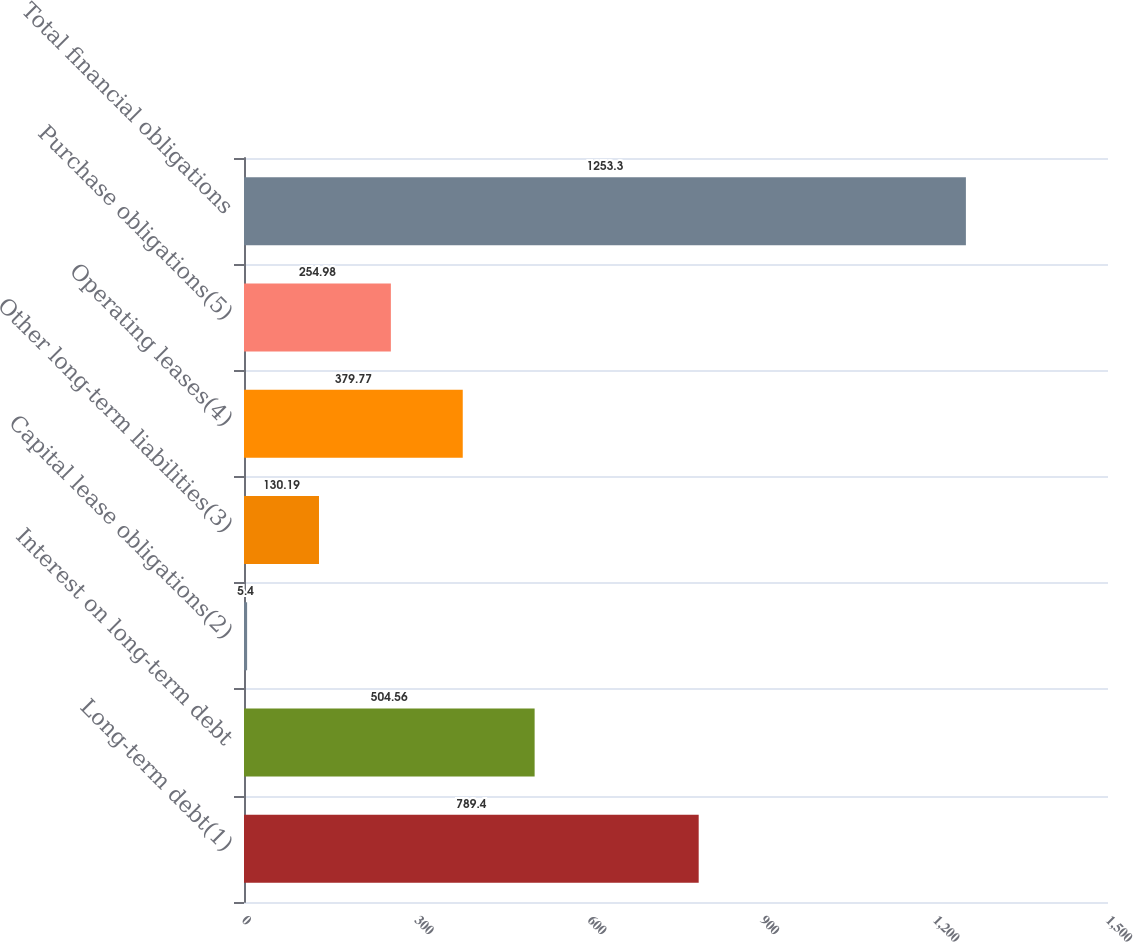Convert chart to OTSL. <chart><loc_0><loc_0><loc_500><loc_500><bar_chart><fcel>Long-term debt(1)<fcel>Interest on long-term debt<fcel>Capital lease obligations(2)<fcel>Other long-term liabilities(3)<fcel>Operating leases(4)<fcel>Purchase obligations(5)<fcel>Total financial obligations<nl><fcel>789.4<fcel>504.56<fcel>5.4<fcel>130.19<fcel>379.77<fcel>254.98<fcel>1253.3<nl></chart> 